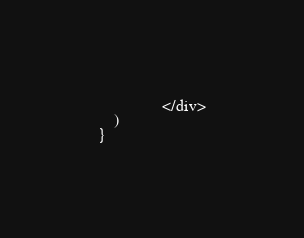<code> <loc_0><loc_0><loc_500><loc_500><_JavaScript_>                </div>
    )
}</code> 